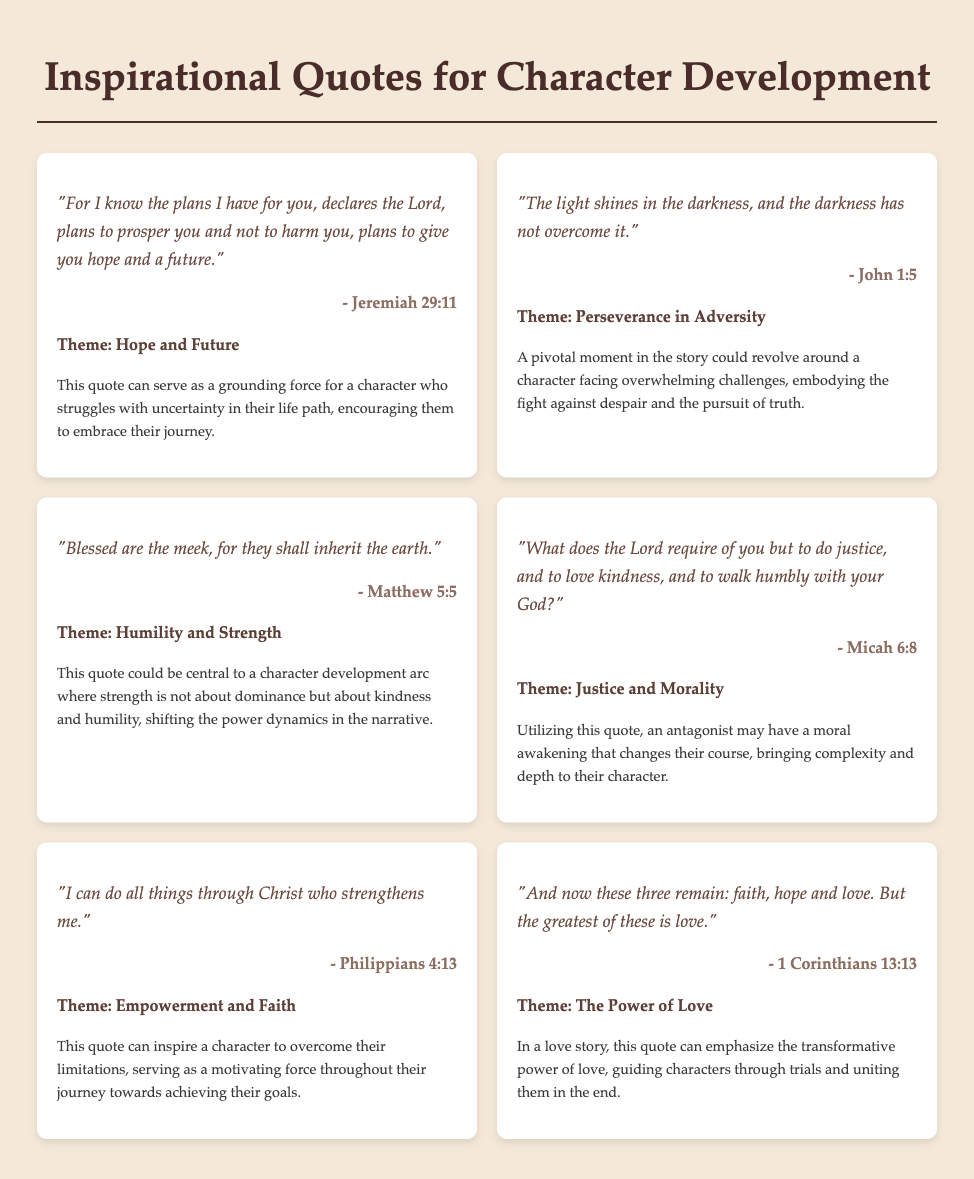What is the title of the document? The title is found at the top of the document and describes the content as related to quotes for storytelling.
Answer: Inspirational Quotes for Character Development How many quotes are included in the document? The document presents a total of six quotes, each contained in its own quote card.
Answer: 6 Which quote discusses the theme of 'Empowerment and Faith'? This information can be found by looking for the theme in the quote cards.
Answer: "I can do all things through Christ who strengthens me." What is the source of the quote about humility? The source is credited at the bottom of the quote card, indicating the biblical reference.
Answer: Matthew 5:5 Which quote emphasizes the theme of 'Justice and Morality'? By checking the themes assigned to the quotes, one can identify which one corresponds to this theme.
Answer: "What does the Lord require of you but to do justice, and to love kindness, and to walk humbly with your God?" In which quote is the idea of 'Hope and Future' expressed? This can be determined by reviewing the themes associated with each quote in the collection.
Answer: "For I know the plans I have for you, declares the Lord, plans to prosper you and not to harm you, plans to give you hope and a future." How does the quote from Philippians 4:13 serve character development? This information can be inferred from the application provided for the quote within the document.
Answer: It inspires a character to overcome limitations 